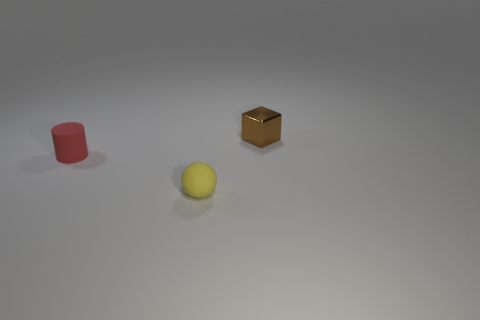Add 2 tiny yellow rubber objects. How many objects exist? 5 Subtract all cubes. How many objects are left? 2 Subtract all red rubber cylinders. Subtract all tiny cylinders. How many objects are left? 1 Add 2 blocks. How many blocks are left? 3 Add 1 tiny red shiny things. How many tiny red shiny things exist? 1 Subtract 0 green blocks. How many objects are left? 3 